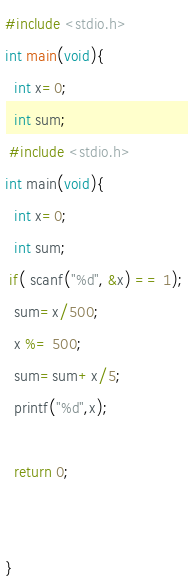<code> <loc_0><loc_0><loc_500><loc_500><_C_>#include <stdio.h>
int main(void){
  int x=0;
  int sum;
 #include <stdio.h>
int main(void){
  int x=0;
  int sum;
 if( scanf("%d", &x) == 1);
  sum=x/500;
  x %= 500;
  sum=sum+x/5;
  printf("%d",x);
  
  return 0;
 
 
}</code> 